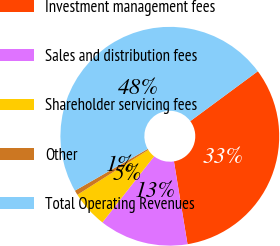Convert chart. <chart><loc_0><loc_0><loc_500><loc_500><pie_chart><fcel>Investment management fees<fcel>Sales and distribution fees<fcel>Shareholder servicing fees<fcel>Other<fcel>Total Operating Revenues<nl><fcel>32.54%<fcel>13.15%<fcel>5.45%<fcel>0.7%<fcel>48.16%<nl></chart> 